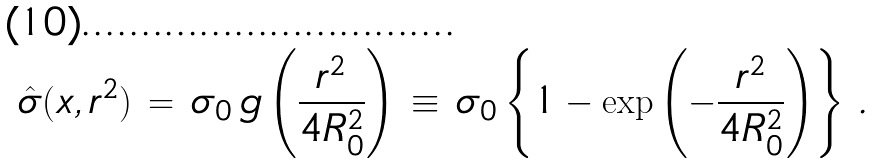Convert formula to latex. <formula><loc_0><loc_0><loc_500><loc_500>\hat { \sigma } ( x , r ^ { 2 } ) \, = \, \sigma _ { 0 } \, g \left ( \frac { r ^ { 2 } } { 4 R _ { 0 } ^ { 2 } } \right ) \, \equiv \, \sigma _ { 0 } \left \{ 1 - \exp \left ( - \frac { r ^ { 2 } } { 4 R _ { 0 } ^ { 2 } } \right ) \right \} \, .</formula> 